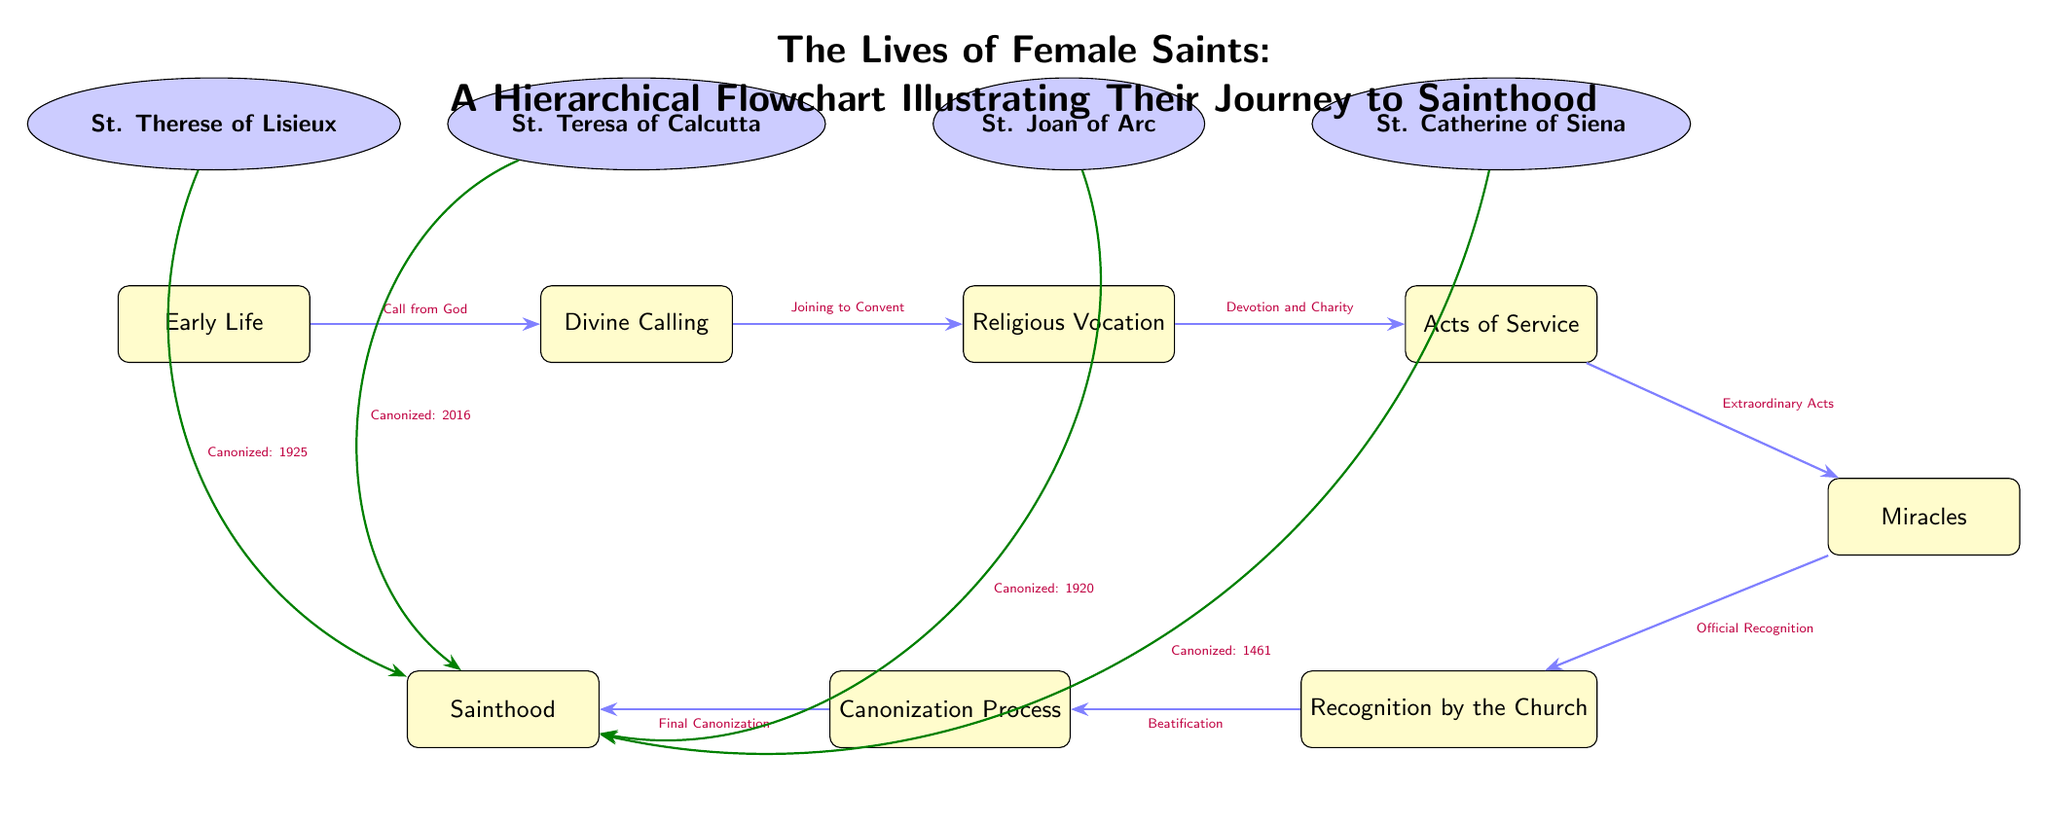What is the first step in the journey to sainthood? The diagram shows that the first step is "Early Life," which is indicated as the initial node in the flowchart.
Answer: Early Life Which saint was canonized in 1925? Referring to the canonical paths in the diagram, St. Therese of Lisieux is directly connected to the canonization date 1925.
Answer: St. Therese of Lisieux How many main path nodes are there in the diagram? The diagram includes a total of seven main path nodes that chronologically lead to sainthood, from "Early Life" to "Sainthood."
Answer: 7 What miraculous act comes directly after "Acts of Service"? According to the flow, the act following "Acts of Service" is "Miracles," as illustrated in the sequence of the diagram.
Answer: Miracles Which saint's divine calling involved joining a convent? The flow between "Divine Calling" and "Religious Vocation" suggests that St. Teresa of Calcutta's journey included joining to a convent, as depicted in the flowchart.
Answer: St. Teresa of Calcutta What is the final stage of the canonization process listed in the diagram? The last node in the canonization process, as shown, is "Final Canonization."
Answer: Final Canonization Which saint's journey illustrates "Devotion and Charity"? St. Joan of Arc is shown to follow the step "Devotion and Charity," based on their place within the flowchart's narrative.
Answer: St. Joan of Arc How many saints are featured in the diagram? The diagram highlights four female saints each associated with key nodes—a straightforward count reveals that there are four saints represented.
Answer: 4 What act leads to official recognition by the Church? "Extraordinary Acts" is the stage that directly leads to the "Official Recognition" of the saints, establishing a clear connection in the diagram.
Answer: Extraordinary Acts 